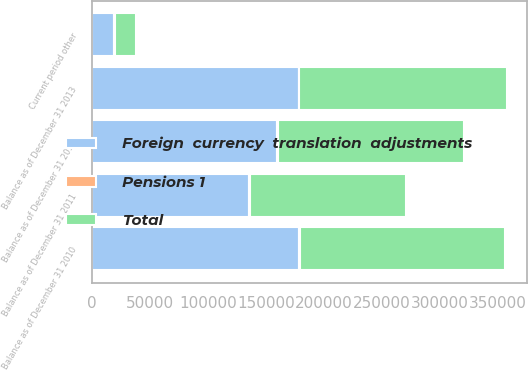Convert chart. <chart><loc_0><loc_0><loc_500><loc_500><stacked_bar_chart><ecel><fcel>Balance as of December 31 2010<fcel>Current period other<fcel>Balance as of December 31 2011<fcel>Balance as of December 31 2012<fcel>Balance as of December 31 2013<nl><fcel>Total<fcel>176982<fcel>18185<fcel>134976<fcel>160661<fcel>178846<nl><fcel>Pensions 1<fcel>1115<fcel>771<fcel>663<fcel>928<fcel>157<nl><fcel>Foreign  currency  translation  adjustments<fcel>178097<fcel>18956<fcel>135639<fcel>159733<fcel>178689<nl></chart> 